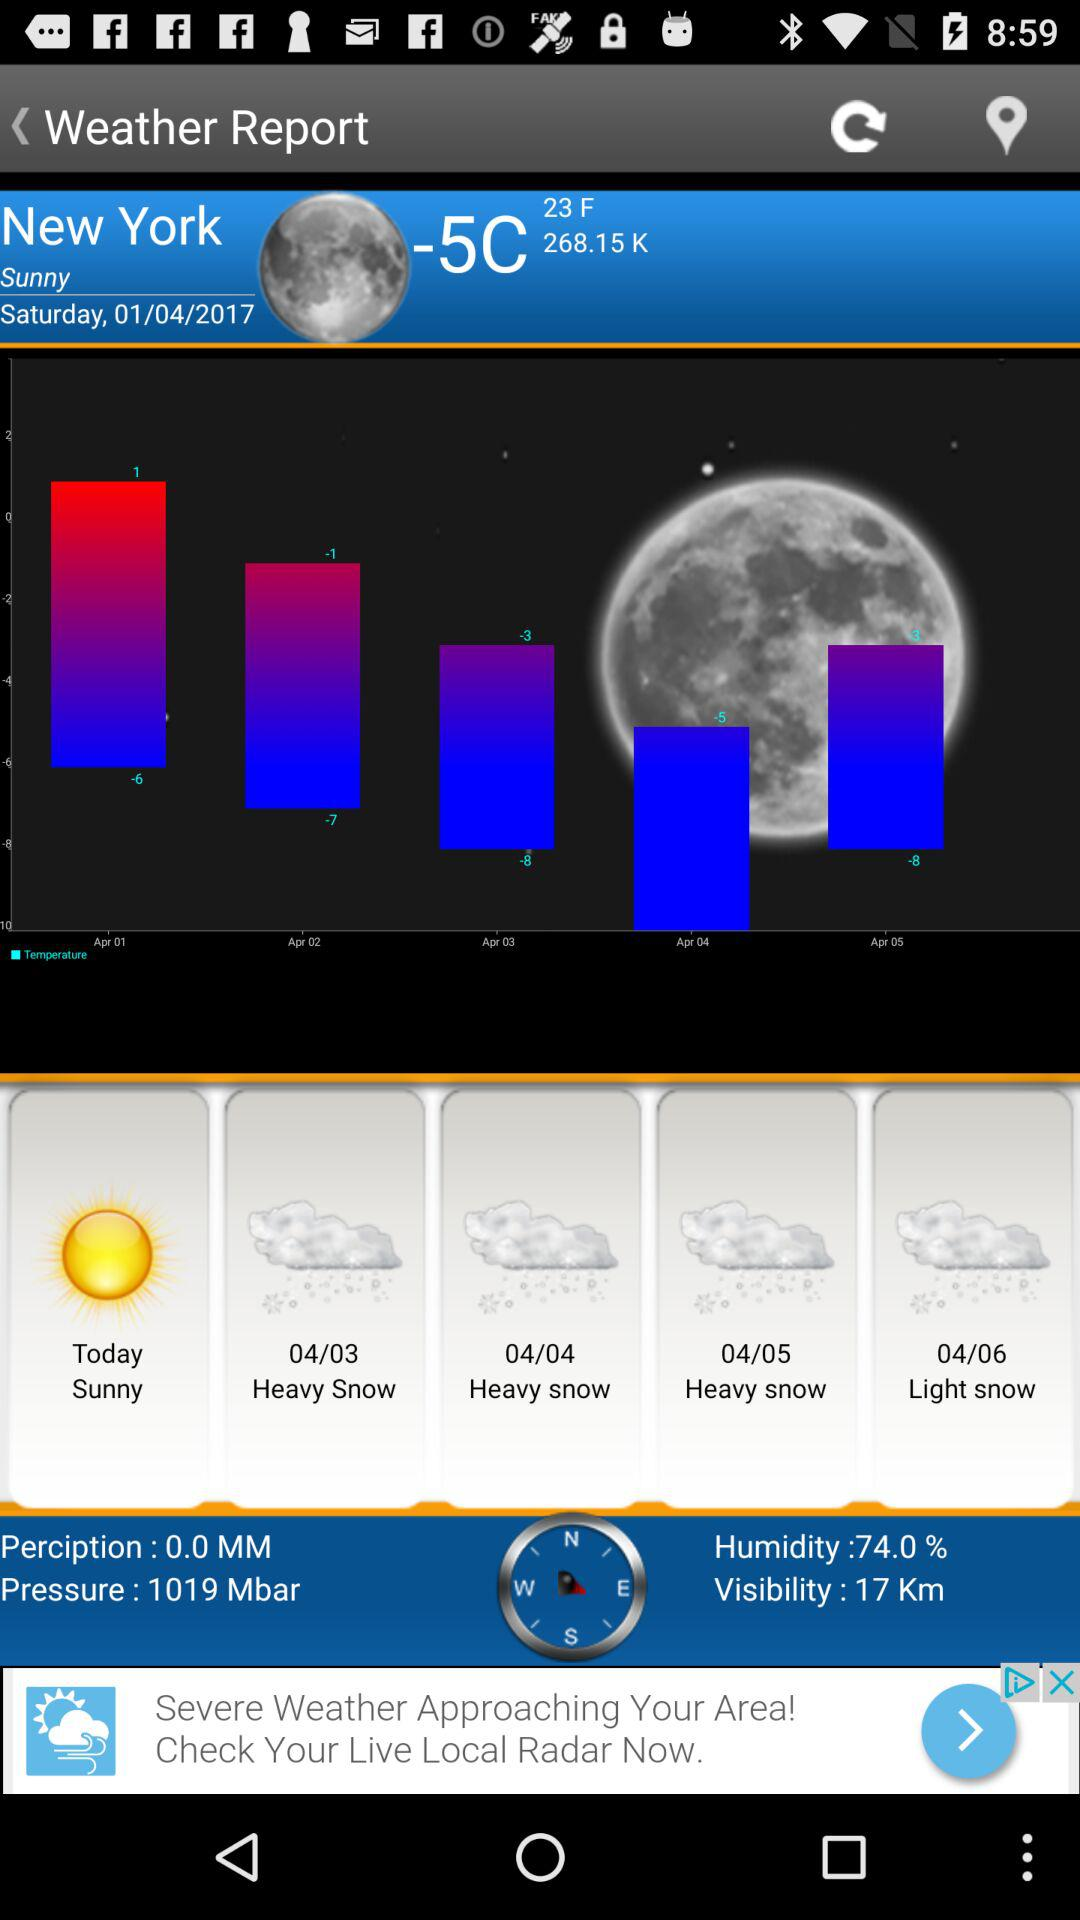What is the given pressure? The given pressure is 1019 mbar. 